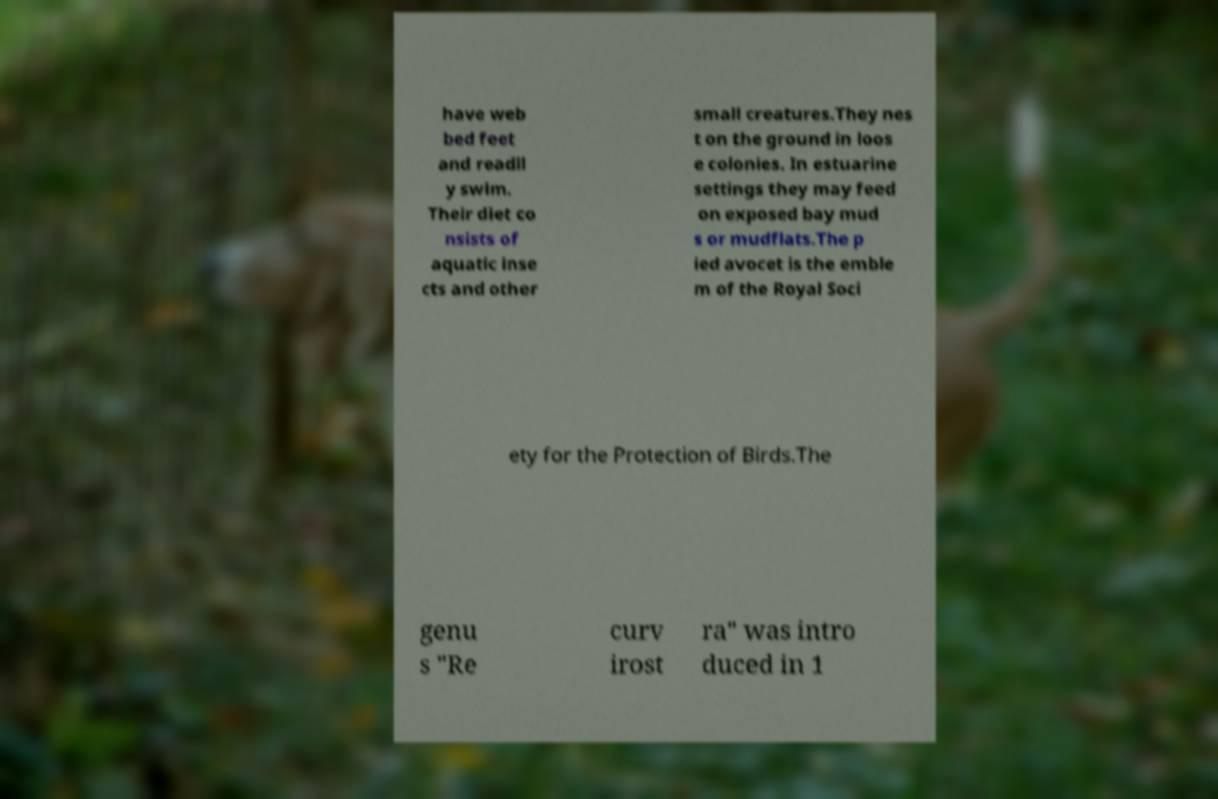Could you assist in decoding the text presented in this image and type it out clearly? have web bed feet and readil y swim. Their diet co nsists of aquatic inse cts and other small creatures.They nes t on the ground in loos e colonies. In estuarine settings they may feed on exposed bay mud s or mudflats.The p ied avocet is the emble m of the Royal Soci ety for the Protection of Birds.The genu s "Re curv irost ra" was intro duced in 1 